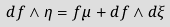Convert formula to latex. <formula><loc_0><loc_0><loc_500><loc_500>d f \land \eta = f \mu + d f \land d \xi</formula> 